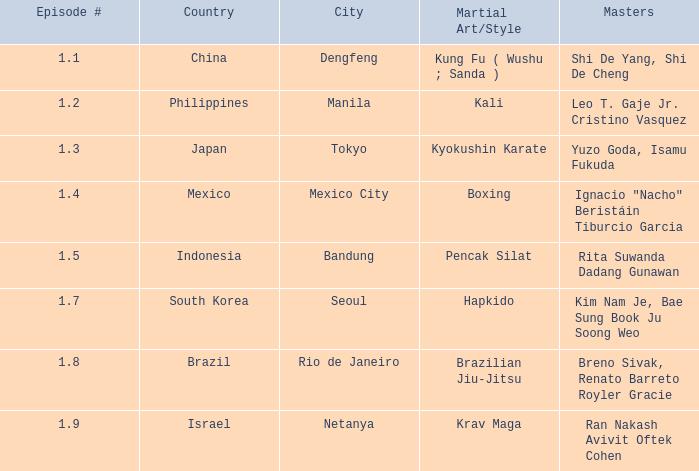Which martial arts form was displayed in rio de janeiro? Brazilian Jiu-Jitsu. 